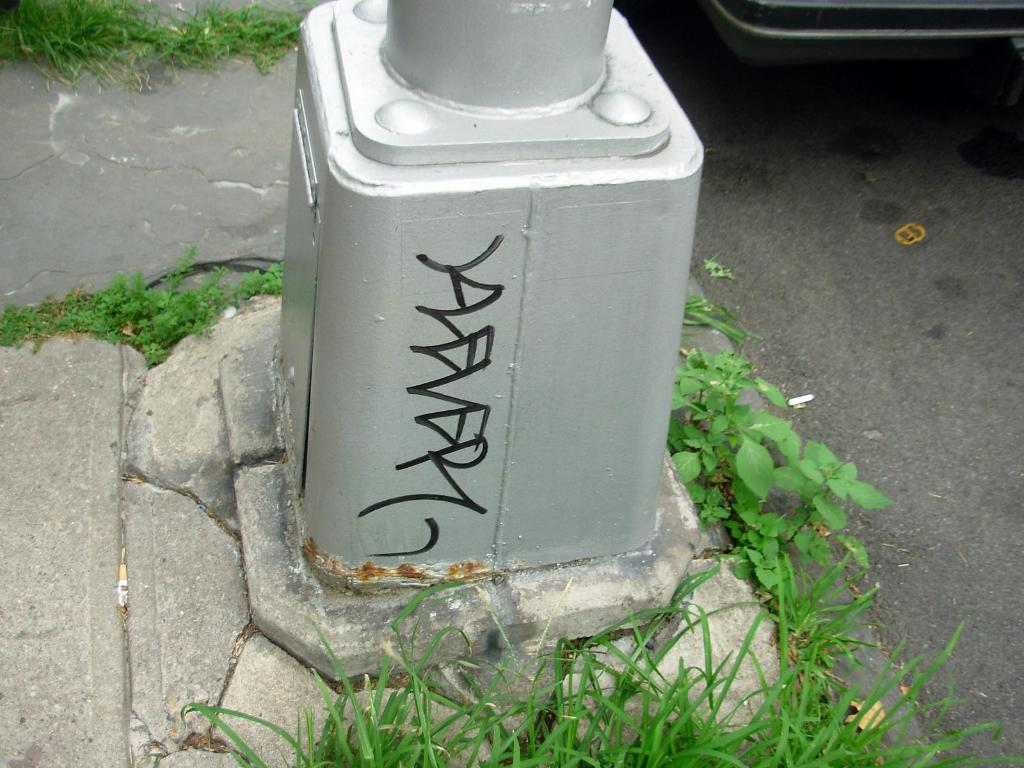What types of living organisms can be seen in the image? Plants and grass are visible in the image. What can be seen in the middle of the image? There is a pole-like object in the middle of the image. Can you taste the grass in the image? It is not possible to taste the grass in the image, as it is a two-dimensional representation and not a real, physical object. 